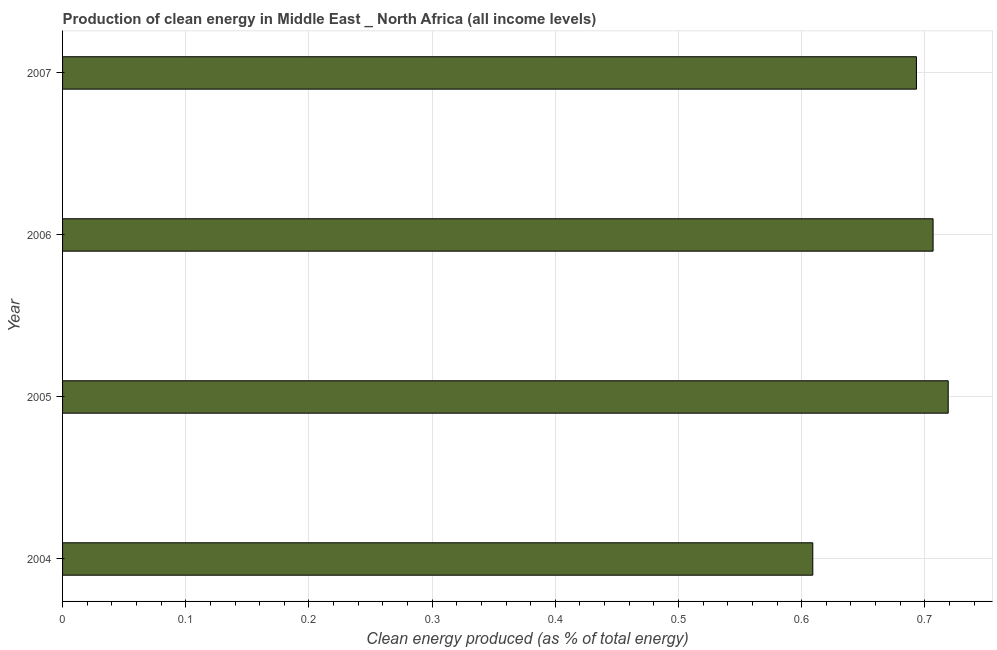Does the graph contain any zero values?
Offer a very short reply. No. What is the title of the graph?
Give a very brief answer. Production of clean energy in Middle East _ North Africa (all income levels). What is the label or title of the X-axis?
Your answer should be very brief. Clean energy produced (as % of total energy). What is the production of clean energy in 2006?
Keep it short and to the point. 0.71. Across all years, what is the maximum production of clean energy?
Give a very brief answer. 0.72. Across all years, what is the minimum production of clean energy?
Provide a short and direct response. 0.61. In which year was the production of clean energy minimum?
Ensure brevity in your answer.  2004. What is the sum of the production of clean energy?
Your response must be concise. 2.73. What is the difference between the production of clean energy in 2005 and 2007?
Your answer should be compact. 0.03. What is the average production of clean energy per year?
Offer a very short reply. 0.68. What is the median production of clean energy?
Offer a terse response. 0.7. In how many years, is the production of clean energy greater than 0.28 %?
Keep it short and to the point. 4. Do a majority of the years between 2006 and 2004 (inclusive) have production of clean energy greater than 0.42 %?
Provide a short and direct response. Yes. Is the production of clean energy in 2005 less than that in 2006?
Keep it short and to the point. No. What is the difference between the highest and the second highest production of clean energy?
Make the answer very short. 0.01. Is the sum of the production of clean energy in 2004 and 2005 greater than the maximum production of clean energy across all years?
Provide a succinct answer. Yes. What is the difference between the highest and the lowest production of clean energy?
Your answer should be compact. 0.11. Are all the bars in the graph horizontal?
Provide a succinct answer. Yes. What is the difference between two consecutive major ticks on the X-axis?
Give a very brief answer. 0.1. Are the values on the major ticks of X-axis written in scientific E-notation?
Keep it short and to the point. No. What is the Clean energy produced (as % of total energy) in 2004?
Your answer should be compact. 0.61. What is the Clean energy produced (as % of total energy) of 2005?
Your response must be concise. 0.72. What is the Clean energy produced (as % of total energy) in 2006?
Ensure brevity in your answer.  0.71. What is the Clean energy produced (as % of total energy) of 2007?
Offer a very short reply. 0.69. What is the difference between the Clean energy produced (as % of total energy) in 2004 and 2005?
Offer a terse response. -0.11. What is the difference between the Clean energy produced (as % of total energy) in 2004 and 2006?
Offer a terse response. -0.1. What is the difference between the Clean energy produced (as % of total energy) in 2004 and 2007?
Make the answer very short. -0.08. What is the difference between the Clean energy produced (as % of total energy) in 2005 and 2006?
Give a very brief answer. 0.01. What is the difference between the Clean energy produced (as % of total energy) in 2005 and 2007?
Make the answer very short. 0.03. What is the difference between the Clean energy produced (as % of total energy) in 2006 and 2007?
Make the answer very short. 0.01. What is the ratio of the Clean energy produced (as % of total energy) in 2004 to that in 2005?
Your answer should be compact. 0.85. What is the ratio of the Clean energy produced (as % of total energy) in 2004 to that in 2006?
Offer a terse response. 0.86. What is the ratio of the Clean energy produced (as % of total energy) in 2004 to that in 2007?
Offer a terse response. 0.88. What is the ratio of the Clean energy produced (as % of total energy) in 2005 to that in 2007?
Provide a succinct answer. 1.04. 